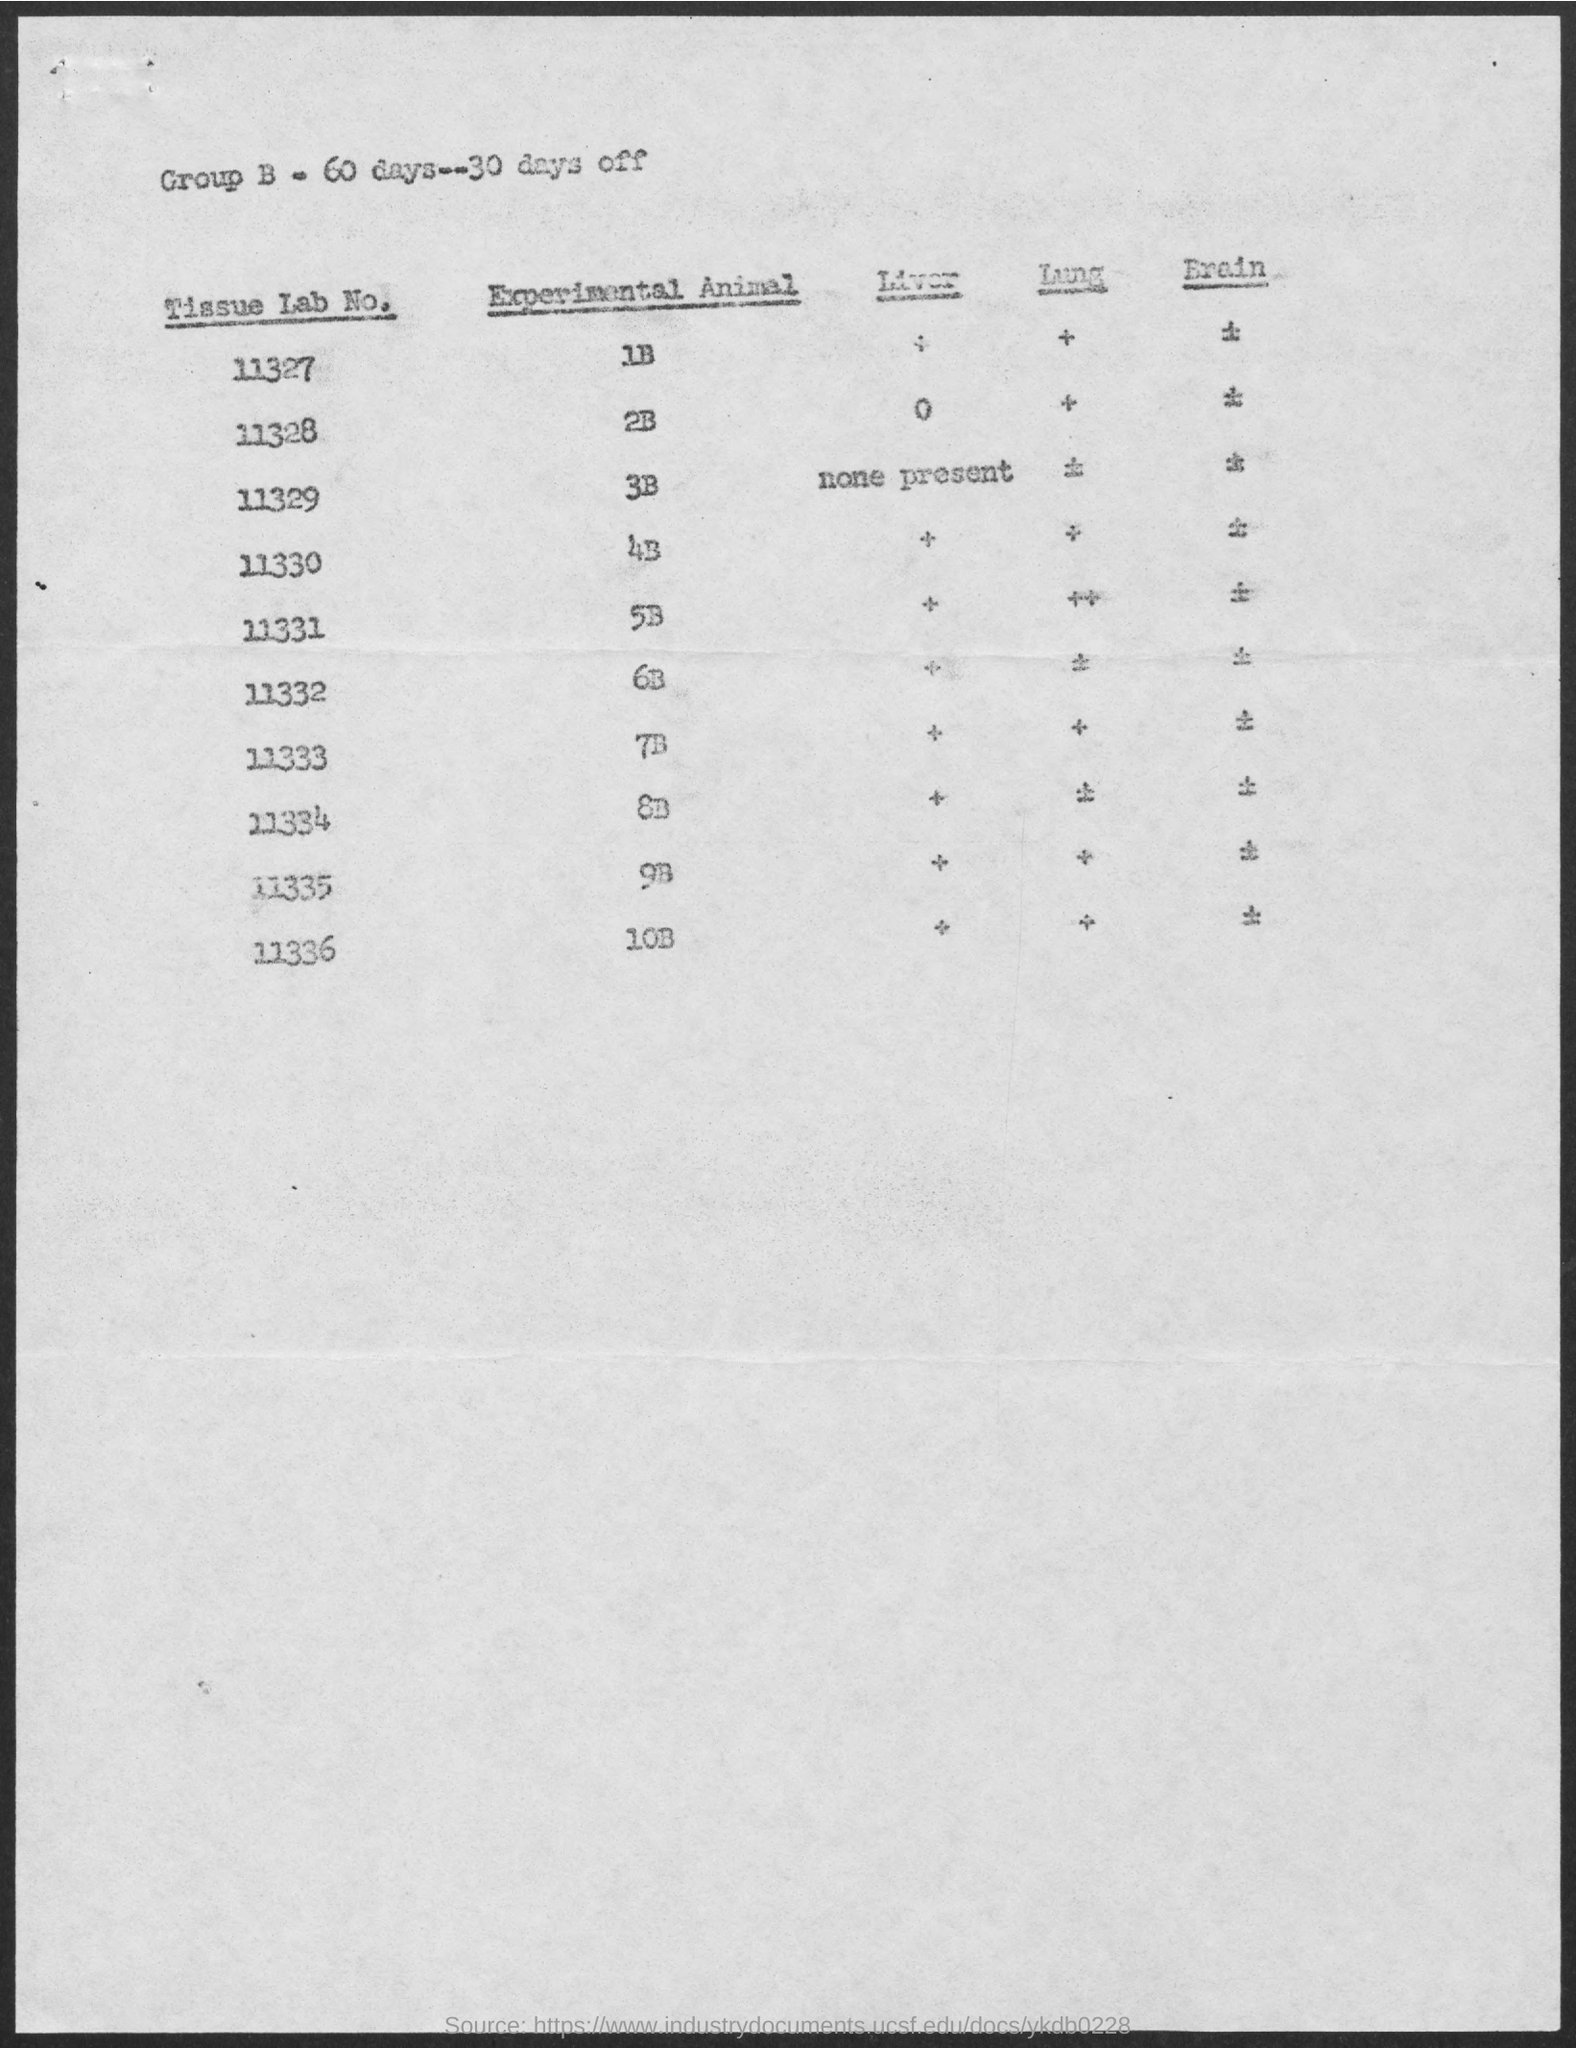How many days for Group B?
Your answer should be compact. 60 days. 